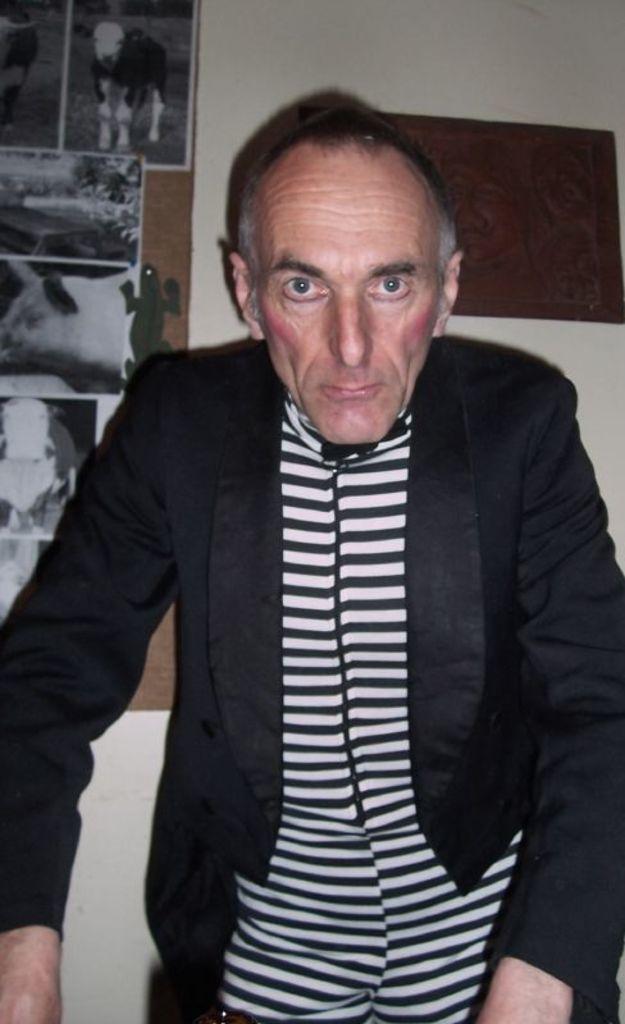How would you summarize this image in a sentence or two? In this image we can see a person wearing black coat is standing on the floor. In the background ,we can see group of photos on the wall. 